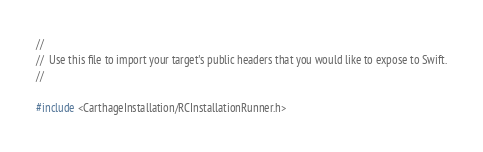<code> <loc_0><loc_0><loc_500><loc_500><_C_>//
//  Use this file to import your target's public headers that you would like to expose to Swift.
//

#include <CarthageInstallation/RCInstallationRunner.h>
</code> 